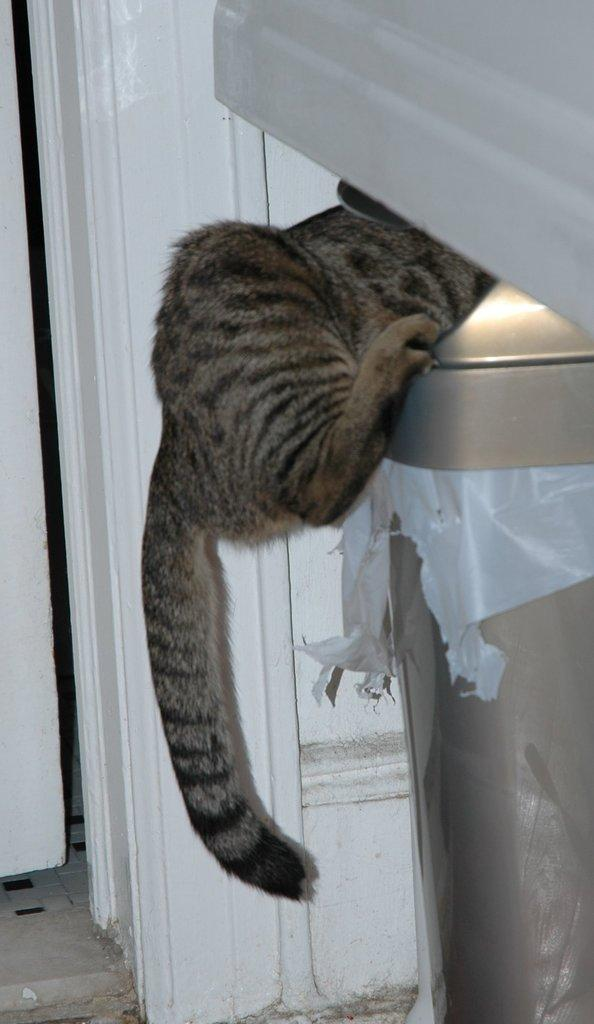What type of creature is in the image? There is an animal in the image. What colors can be seen on the animal? The animal is in brown and black colors. What is the animal standing on? The animal is standing on some object. What can be seen in the background of the image? There is a door in the background of the image. What color is the door? The door is white in color. How many rabbits are involved in the agreement depicted in the image? There are no rabbits or agreements present in the image. The image features an animal standing on an object with a white door in the background. 